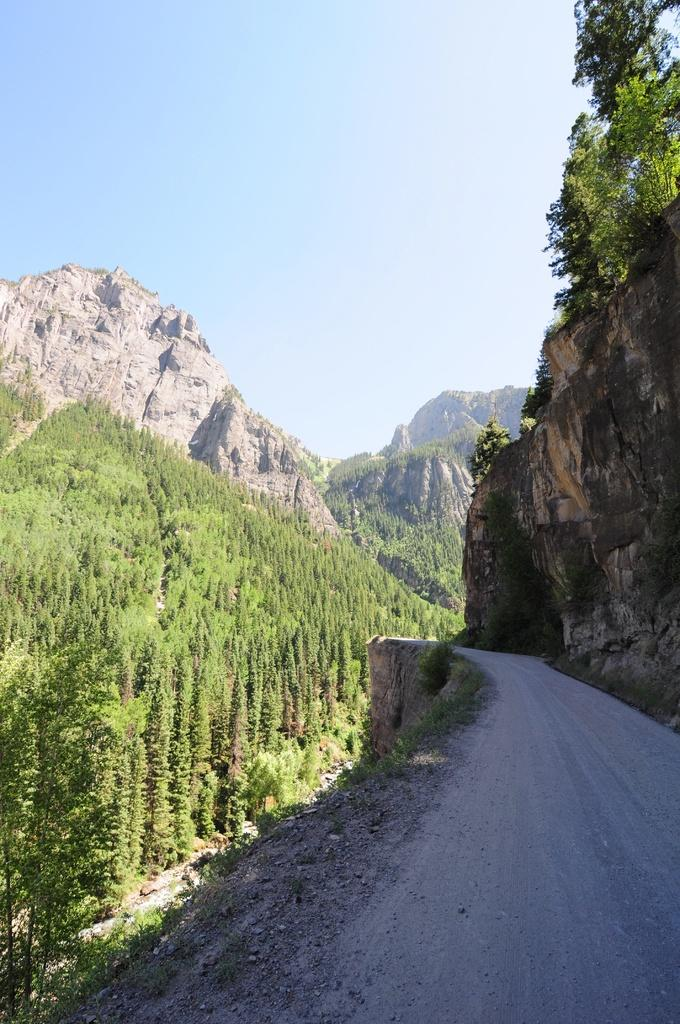What type of vegetation is present in the image? There is a group of trees in the image. What can be seen on the right side of the image? There is a pathway on the right side of the image. What is visible in the background of the image? Hills and the sky are visible in the background of the image. What type of marble is used to decorate the trees in the image? There is no marble present in the image; it features a group of trees and other natural elements. 